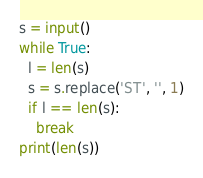<code> <loc_0><loc_0><loc_500><loc_500><_Python_>s = input()
while True:
  l = len(s)
  s = s.replace('ST', '', 1)
  if l == len(s):
    break
print(len(s))
</code> 